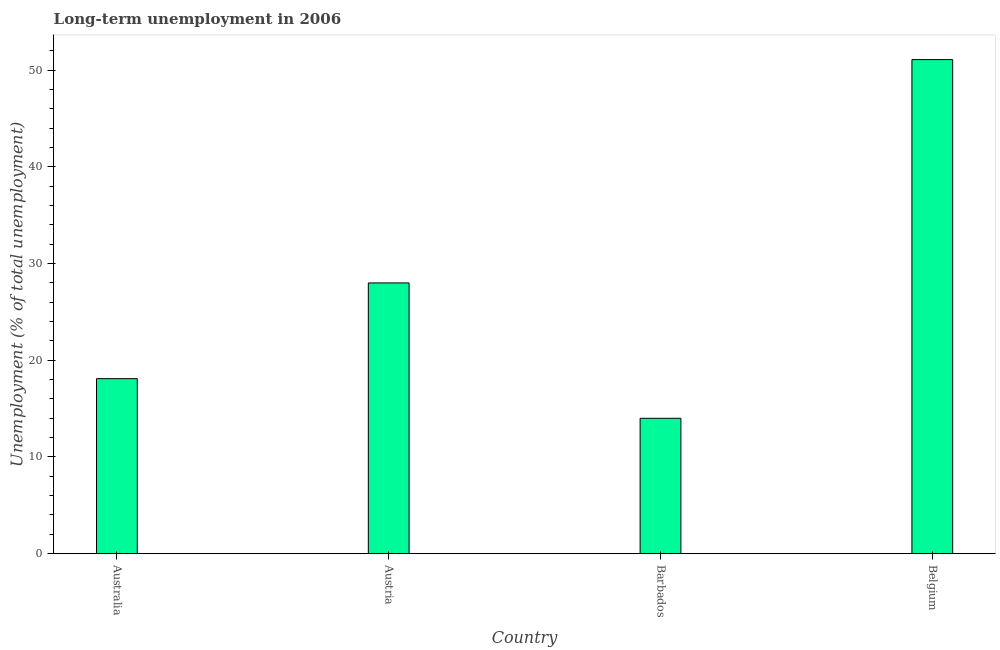Does the graph contain grids?
Give a very brief answer. No. What is the title of the graph?
Your response must be concise. Long-term unemployment in 2006. What is the label or title of the Y-axis?
Your response must be concise. Unemployment (% of total unemployment). Across all countries, what is the maximum long-term unemployment?
Your response must be concise. 51.1. Across all countries, what is the minimum long-term unemployment?
Provide a short and direct response. 14. In which country was the long-term unemployment minimum?
Your answer should be very brief. Barbados. What is the sum of the long-term unemployment?
Provide a short and direct response. 111.2. What is the average long-term unemployment per country?
Keep it short and to the point. 27.8. What is the median long-term unemployment?
Your answer should be compact. 23.05. What is the ratio of the long-term unemployment in Barbados to that in Belgium?
Your response must be concise. 0.27. Is the long-term unemployment in Australia less than that in Barbados?
Provide a succinct answer. No. What is the difference between the highest and the second highest long-term unemployment?
Your answer should be very brief. 23.1. What is the difference between the highest and the lowest long-term unemployment?
Your answer should be compact. 37.1. In how many countries, is the long-term unemployment greater than the average long-term unemployment taken over all countries?
Offer a terse response. 2. How many countries are there in the graph?
Keep it short and to the point. 4. What is the Unemployment (% of total unemployment) of Australia?
Make the answer very short. 18.1. What is the Unemployment (% of total unemployment) in Austria?
Make the answer very short. 28. What is the Unemployment (% of total unemployment) of Belgium?
Give a very brief answer. 51.1. What is the difference between the Unemployment (% of total unemployment) in Australia and Barbados?
Provide a short and direct response. 4.1. What is the difference between the Unemployment (% of total unemployment) in Australia and Belgium?
Your answer should be compact. -33. What is the difference between the Unemployment (% of total unemployment) in Austria and Barbados?
Make the answer very short. 14. What is the difference between the Unemployment (% of total unemployment) in Austria and Belgium?
Your answer should be very brief. -23.1. What is the difference between the Unemployment (% of total unemployment) in Barbados and Belgium?
Keep it short and to the point. -37.1. What is the ratio of the Unemployment (% of total unemployment) in Australia to that in Austria?
Your response must be concise. 0.65. What is the ratio of the Unemployment (% of total unemployment) in Australia to that in Barbados?
Make the answer very short. 1.29. What is the ratio of the Unemployment (% of total unemployment) in Australia to that in Belgium?
Offer a very short reply. 0.35. What is the ratio of the Unemployment (% of total unemployment) in Austria to that in Belgium?
Your response must be concise. 0.55. What is the ratio of the Unemployment (% of total unemployment) in Barbados to that in Belgium?
Provide a succinct answer. 0.27. 